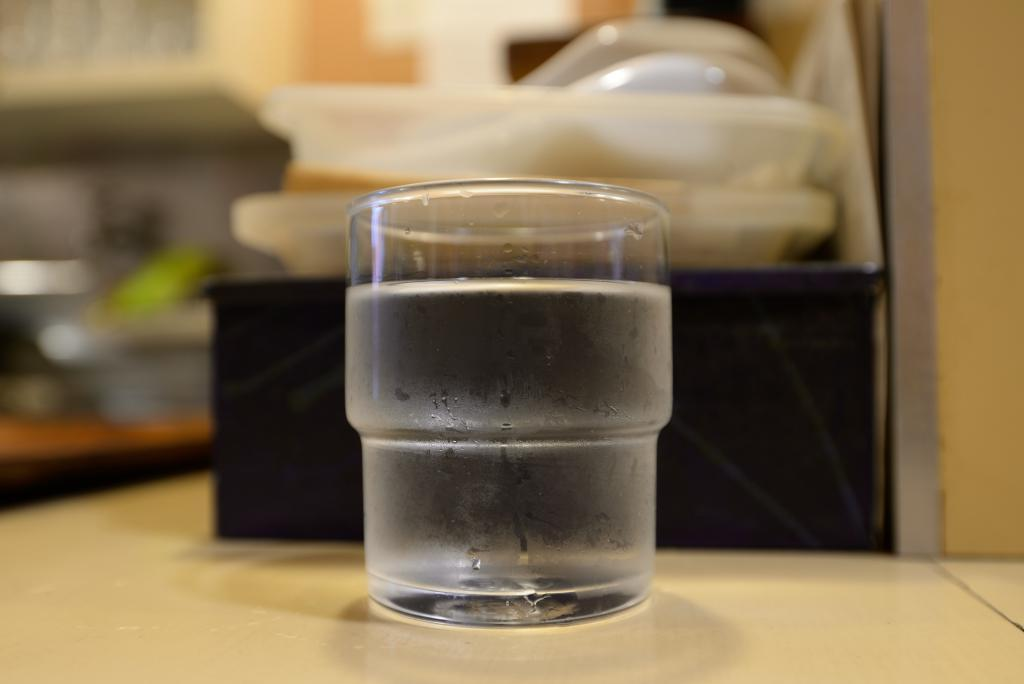What is in the glass that is visible in the image? There is a glass of drink in the image. What other items can be seen in the background of the image? There are plastic bowls visible in the background of the image. How would you describe the background of the image? The background of the image is blurry. How many deer are visible in the image? There are no deer present in the image. What type of polish is being applied to the glass in the image? There is no polish being applied to the glass in the image; it is a glass of drink. 